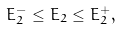<formula> <loc_0><loc_0><loc_500><loc_500>E _ { 2 } ^ { - } \leq E _ { 2 } \leq E _ { 2 } ^ { + } ,</formula> 